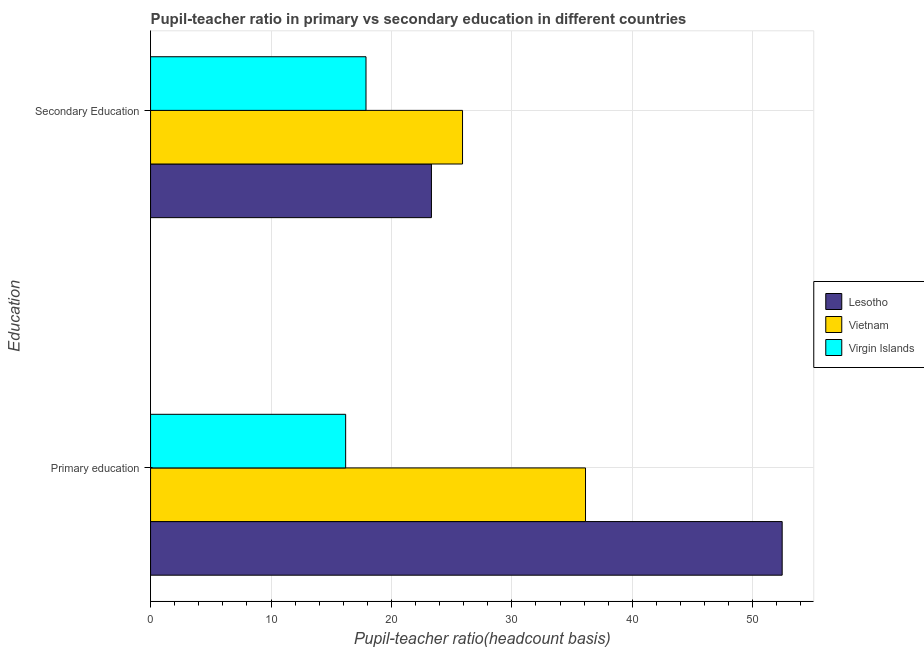Are the number of bars per tick equal to the number of legend labels?
Make the answer very short. Yes. What is the label of the 2nd group of bars from the top?
Provide a succinct answer. Primary education. What is the pupil-teacher ratio in primary education in Virgin Islands?
Give a very brief answer. 16.2. Across all countries, what is the maximum pupil-teacher ratio in primary education?
Provide a succinct answer. 52.45. Across all countries, what is the minimum pupil-teacher ratio in primary education?
Offer a very short reply. 16.2. In which country was the pupil teacher ratio on secondary education maximum?
Give a very brief answer. Vietnam. In which country was the pupil-teacher ratio in primary education minimum?
Give a very brief answer. Virgin Islands. What is the total pupil teacher ratio on secondary education in the graph?
Offer a terse response. 67.12. What is the difference between the pupil teacher ratio on secondary education in Vietnam and that in Lesotho?
Provide a succinct answer. 2.58. What is the difference between the pupil teacher ratio on secondary education in Vietnam and the pupil-teacher ratio in primary education in Virgin Islands?
Your response must be concise. 9.71. What is the average pupil teacher ratio on secondary education per country?
Provide a short and direct response. 22.37. What is the difference between the pupil-teacher ratio in primary education and pupil teacher ratio on secondary education in Vietnam?
Your response must be concise. 10.21. What is the ratio of the pupil teacher ratio on secondary education in Virgin Islands to that in Vietnam?
Provide a short and direct response. 0.69. Is the pupil-teacher ratio in primary education in Lesotho less than that in Vietnam?
Provide a short and direct response. No. What does the 2nd bar from the top in Primary education represents?
Ensure brevity in your answer.  Vietnam. What does the 3rd bar from the bottom in Secondary Education represents?
Give a very brief answer. Virgin Islands. Are all the bars in the graph horizontal?
Ensure brevity in your answer.  Yes. Does the graph contain any zero values?
Make the answer very short. No. Does the graph contain grids?
Keep it short and to the point. Yes. How many legend labels are there?
Provide a short and direct response. 3. What is the title of the graph?
Your response must be concise. Pupil-teacher ratio in primary vs secondary education in different countries. Does "Senegal" appear as one of the legend labels in the graph?
Your answer should be very brief. No. What is the label or title of the X-axis?
Ensure brevity in your answer.  Pupil-teacher ratio(headcount basis). What is the label or title of the Y-axis?
Make the answer very short. Education. What is the Pupil-teacher ratio(headcount basis) of Lesotho in Primary education?
Keep it short and to the point. 52.45. What is the Pupil-teacher ratio(headcount basis) of Vietnam in Primary education?
Your response must be concise. 36.12. What is the Pupil-teacher ratio(headcount basis) in Virgin Islands in Primary education?
Make the answer very short. 16.2. What is the Pupil-teacher ratio(headcount basis) of Lesotho in Secondary Education?
Offer a terse response. 23.32. What is the Pupil-teacher ratio(headcount basis) of Vietnam in Secondary Education?
Ensure brevity in your answer.  25.9. What is the Pupil-teacher ratio(headcount basis) in Virgin Islands in Secondary Education?
Your answer should be compact. 17.89. Across all Education, what is the maximum Pupil-teacher ratio(headcount basis) of Lesotho?
Offer a very short reply. 52.45. Across all Education, what is the maximum Pupil-teacher ratio(headcount basis) of Vietnam?
Offer a very short reply. 36.12. Across all Education, what is the maximum Pupil-teacher ratio(headcount basis) in Virgin Islands?
Your answer should be very brief. 17.89. Across all Education, what is the minimum Pupil-teacher ratio(headcount basis) of Lesotho?
Your answer should be compact. 23.32. Across all Education, what is the minimum Pupil-teacher ratio(headcount basis) in Vietnam?
Your response must be concise. 25.9. Across all Education, what is the minimum Pupil-teacher ratio(headcount basis) in Virgin Islands?
Make the answer very short. 16.2. What is the total Pupil-teacher ratio(headcount basis) in Lesotho in the graph?
Offer a terse response. 75.77. What is the total Pupil-teacher ratio(headcount basis) of Vietnam in the graph?
Give a very brief answer. 62.02. What is the total Pupil-teacher ratio(headcount basis) of Virgin Islands in the graph?
Give a very brief answer. 34.09. What is the difference between the Pupil-teacher ratio(headcount basis) of Lesotho in Primary education and that in Secondary Education?
Offer a terse response. 29.12. What is the difference between the Pupil-teacher ratio(headcount basis) in Vietnam in Primary education and that in Secondary Education?
Provide a succinct answer. 10.21. What is the difference between the Pupil-teacher ratio(headcount basis) of Virgin Islands in Primary education and that in Secondary Education?
Provide a succinct answer. -1.69. What is the difference between the Pupil-teacher ratio(headcount basis) in Lesotho in Primary education and the Pupil-teacher ratio(headcount basis) in Vietnam in Secondary Education?
Your response must be concise. 26.54. What is the difference between the Pupil-teacher ratio(headcount basis) in Lesotho in Primary education and the Pupil-teacher ratio(headcount basis) in Virgin Islands in Secondary Education?
Offer a very short reply. 34.56. What is the difference between the Pupil-teacher ratio(headcount basis) in Vietnam in Primary education and the Pupil-teacher ratio(headcount basis) in Virgin Islands in Secondary Education?
Make the answer very short. 18.23. What is the average Pupil-teacher ratio(headcount basis) of Lesotho per Education?
Keep it short and to the point. 37.88. What is the average Pupil-teacher ratio(headcount basis) of Vietnam per Education?
Provide a short and direct response. 31.01. What is the average Pupil-teacher ratio(headcount basis) in Virgin Islands per Education?
Offer a terse response. 17.04. What is the difference between the Pupil-teacher ratio(headcount basis) in Lesotho and Pupil-teacher ratio(headcount basis) in Vietnam in Primary education?
Your response must be concise. 16.33. What is the difference between the Pupil-teacher ratio(headcount basis) of Lesotho and Pupil-teacher ratio(headcount basis) of Virgin Islands in Primary education?
Provide a short and direct response. 36.25. What is the difference between the Pupil-teacher ratio(headcount basis) in Vietnam and Pupil-teacher ratio(headcount basis) in Virgin Islands in Primary education?
Keep it short and to the point. 19.92. What is the difference between the Pupil-teacher ratio(headcount basis) in Lesotho and Pupil-teacher ratio(headcount basis) in Vietnam in Secondary Education?
Keep it short and to the point. -2.58. What is the difference between the Pupil-teacher ratio(headcount basis) in Lesotho and Pupil-teacher ratio(headcount basis) in Virgin Islands in Secondary Education?
Provide a short and direct response. 5.43. What is the difference between the Pupil-teacher ratio(headcount basis) of Vietnam and Pupil-teacher ratio(headcount basis) of Virgin Islands in Secondary Education?
Keep it short and to the point. 8.02. What is the ratio of the Pupil-teacher ratio(headcount basis) of Lesotho in Primary education to that in Secondary Education?
Provide a succinct answer. 2.25. What is the ratio of the Pupil-teacher ratio(headcount basis) of Vietnam in Primary education to that in Secondary Education?
Provide a succinct answer. 1.39. What is the ratio of the Pupil-teacher ratio(headcount basis) of Virgin Islands in Primary education to that in Secondary Education?
Give a very brief answer. 0.91. What is the difference between the highest and the second highest Pupil-teacher ratio(headcount basis) of Lesotho?
Ensure brevity in your answer.  29.12. What is the difference between the highest and the second highest Pupil-teacher ratio(headcount basis) of Vietnam?
Your answer should be compact. 10.21. What is the difference between the highest and the second highest Pupil-teacher ratio(headcount basis) of Virgin Islands?
Your response must be concise. 1.69. What is the difference between the highest and the lowest Pupil-teacher ratio(headcount basis) in Lesotho?
Keep it short and to the point. 29.12. What is the difference between the highest and the lowest Pupil-teacher ratio(headcount basis) in Vietnam?
Your response must be concise. 10.21. What is the difference between the highest and the lowest Pupil-teacher ratio(headcount basis) in Virgin Islands?
Provide a short and direct response. 1.69. 